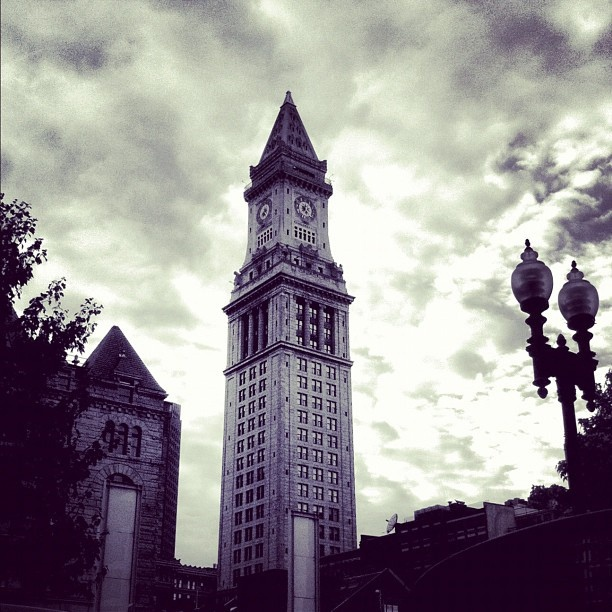Describe the objects in this image and their specific colors. I can see clock in gray, purple, and darkgray tones and clock in gray, purple, and darkgray tones in this image. 